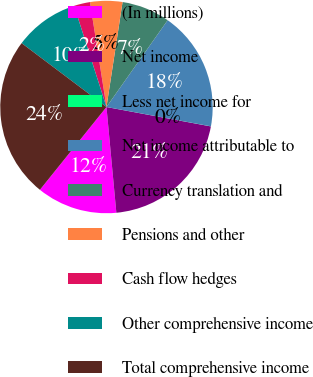Convert chart. <chart><loc_0><loc_0><loc_500><loc_500><pie_chart><fcel>(In millions)<fcel>Net income<fcel>Less net income for<fcel>Net income attributable to<fcel>Currency translation and<fcel>Pensions and other<fcel>Cash flow hedges<fcel>Other comprehensive income<fcel>Total comprehensive income<nl><fcel>12.26%<fcel>20.59%<fcel>0.01%<fcel>18.14%<fcel>7.35%<fcel>4.9%<fcel>2.45%<fcel>9.8%<fcel>24.49%<nl></chart> 